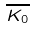<formula> <loc_0><loc_0><loc_500><loc_500>\overline { K _ { 0 } }</formula> 